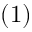Convert formula to latex. <formula><loc_0><loc_0><loc_500><loc_500>( 1 )</formula> 